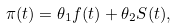<formula> <loc_0><loc_0><loc_500><loc_500>\pi ( t ) = \theta _ { 1 } f ( t ) + \theta _ { 2 } S ( t ) ,</formula> 